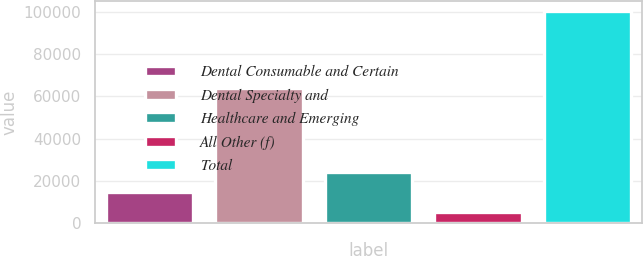Convert chart to OTSL. <chart><loc_0><loc_0><loc_500><loc_500><bar_chart><fcel>Dental Consumable and Certain<fcel>Dental Specialty and<fcel>Healthcare and Emerging<fcel>All Other (f)<fcel>Total<nl><fcel>14821.6<fcel>64084<fcel>24324.2<fcel>5319<fcel>100345<nl></chart> 